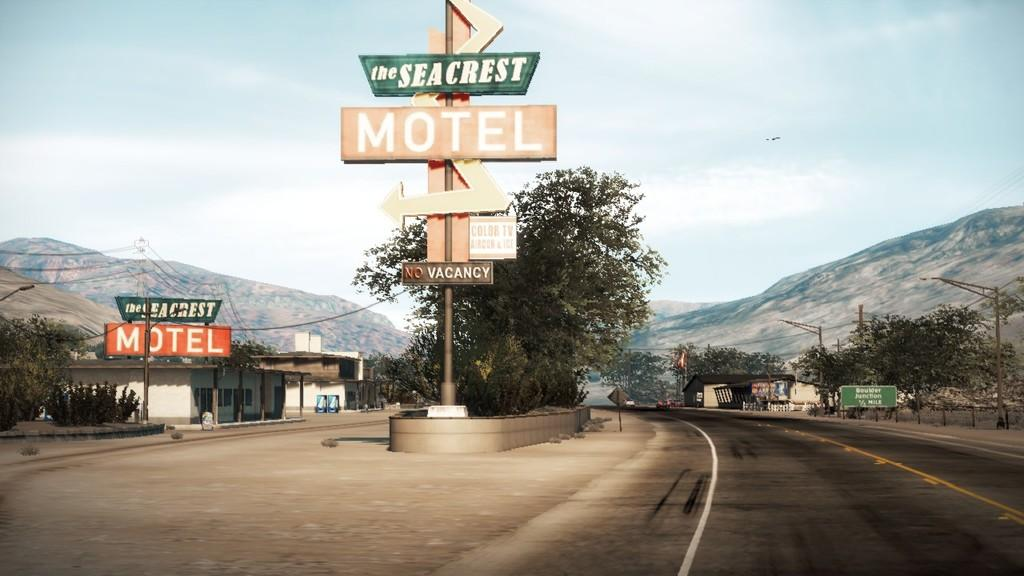Provide a one-sentence caption for the provided image. Several signs display the Seacrest Motel has color TV. 